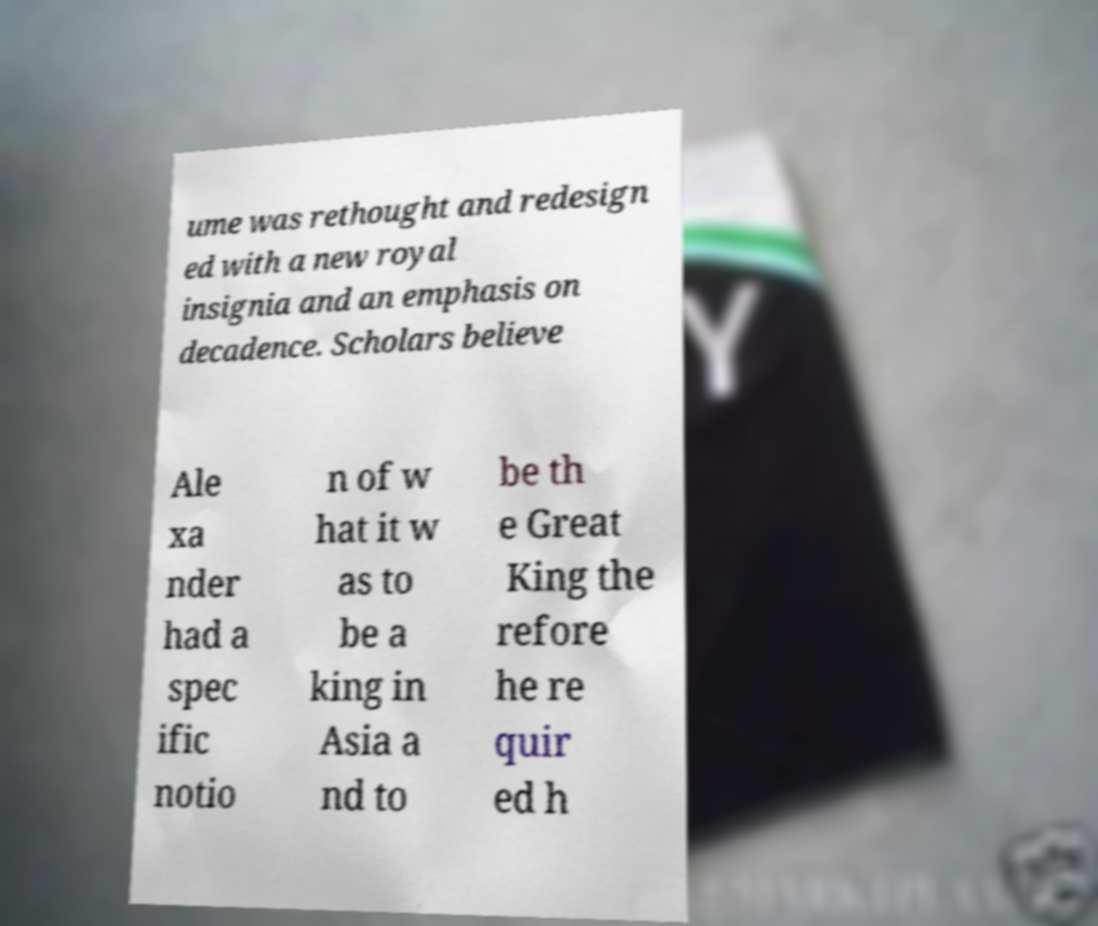There's text embedded in this image that I need extracted. Can you transcribe it verbatim? ume was rethought and redesign ed with a new royal insignia and an emphasis on decadence. Scholars believe Ale xa nder had a spec ific notio n of w hat it w as to be a king in Asia a nd to be th e Great King the refore he re quir ed h 